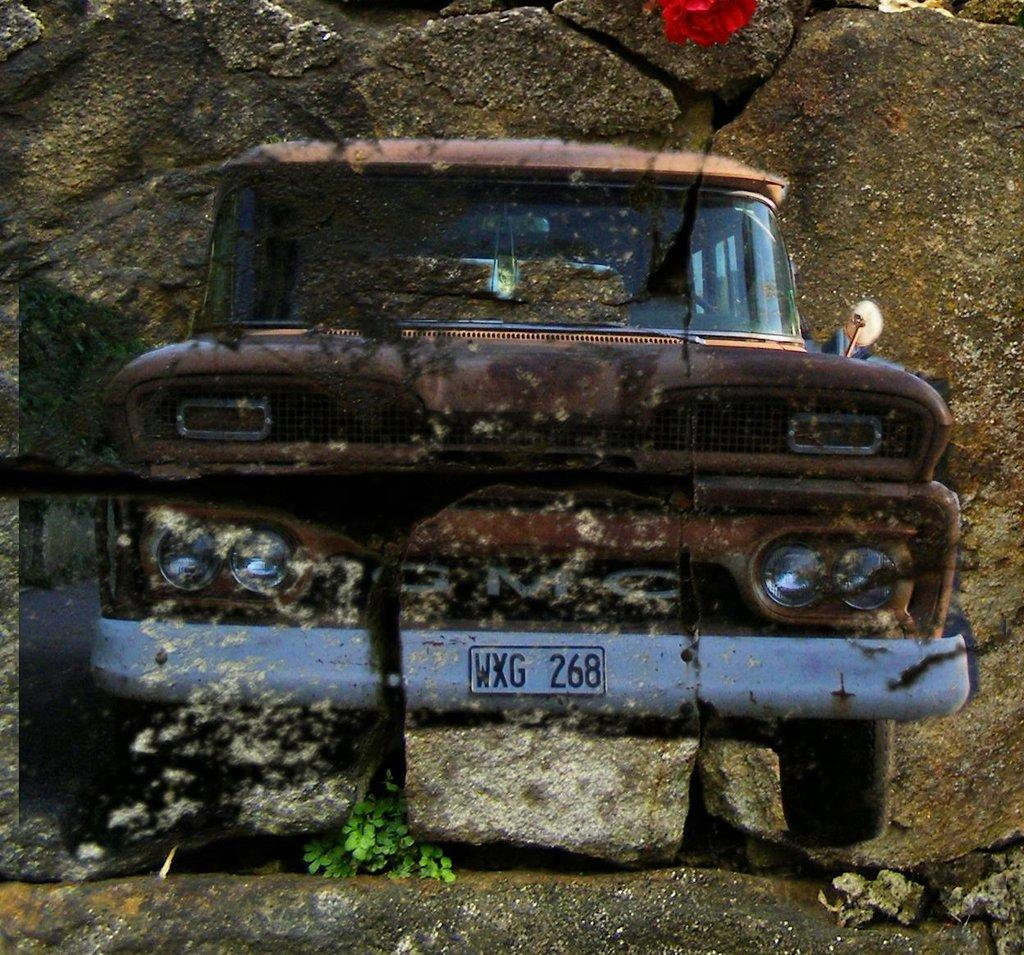What is the main subject of the image? The main subject of the image is a car. Can you describe the background of the image? There is a wall in the background of the image. What type of quiver is the baby holding in the image? There is no baby or quiver present in the image; it features a car and a wall in the background. 